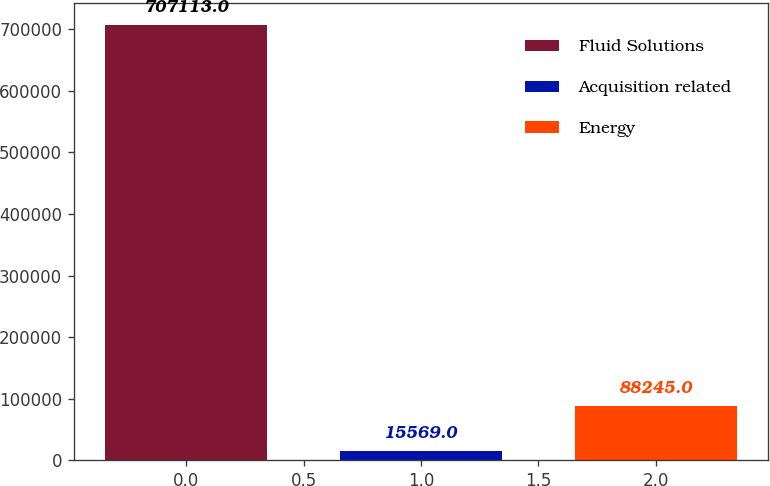<chart> <loc_0><loc_0><loc_500><loc_500><bar_chart><fcel>Fluid Solutions<fcel>Acquisition related<fcel>Energy<nl><fcel>707113<fcel>15569<fcel>88245<nl></chart> 